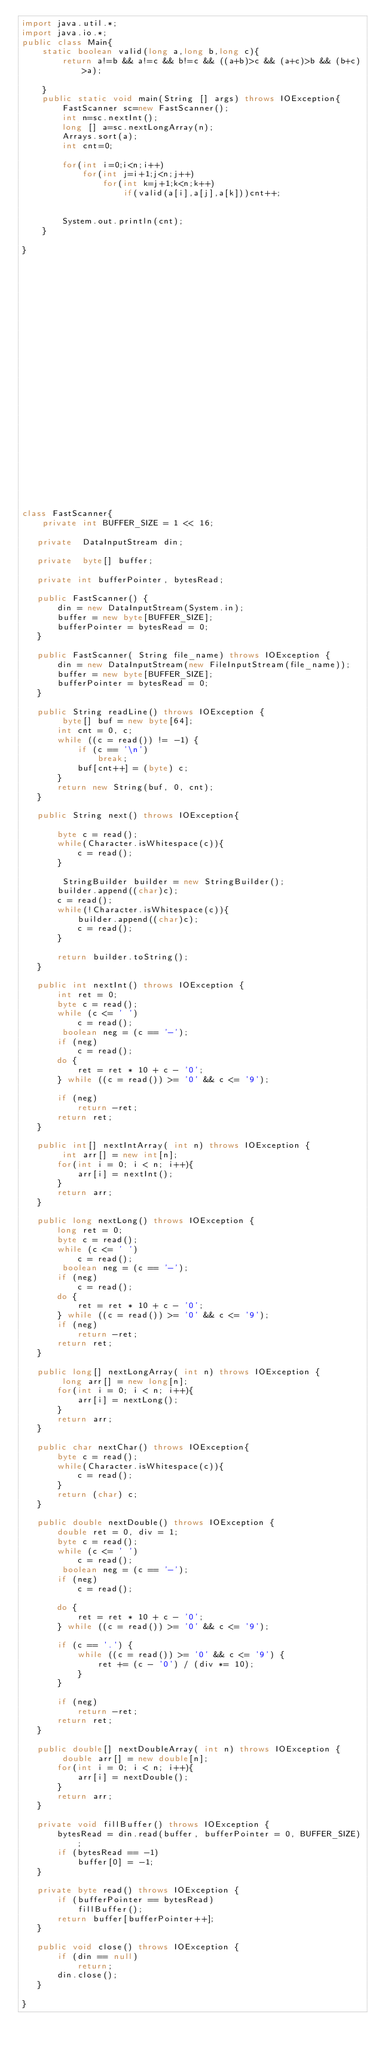Convert code to text. <code><loc_0><loc_0><loc_500><loc_500><_Java_>import java.util.*;
import java.io.*;
public class Main{
    static boolean valid(long a,long b,long c){
        return a!=b && a!=c && b!=c && ((a+b)>c && (a+c)>b && (b+c)>a);

    }
    public static void main(String [] args) throws IOException{
        FastScanner sc=new FastScanner();
        int n=sc.nextInt();
        long [] a=sc.nextLongArray(n);
        Arrays.sort(a);
        int cnt=0;

        for(int i=0;i<n;i++)
            for(int j=i+1;j<n;j++)
                for(int k=j+1;k<n;k++)
                    if(valid(a[i],a[j],a[k]))cnt++;


        System.out.println(cnt);
    }

}



























class FastScanner{	
    private int BUFFER_SIZE = 1 << 16;
   
   private  DataInputStream din;
   
   private  byte[] buffer;
   
   private int bufferPointer, bytesRead;
   
   public FastScanner() {
       din = new DataInputStream(System.in);
       buffer = new byte[BUFFER_SIZE];
       bufferPointer = bytesRead = 0;
   }

   public FastScanner( String file_name) throws IOException {
       din = new DataInputStream(new FileInputStream(file_name));
       buffer = new byte[BUFFER_SIZE];
       bufferPointer = bytesRead = 0;
   }
   
   public String readLine() throws IOException {
        byte[] buf = new byte[64];
       int cnt = 0, c;
       while ((c = read()) != -1) {
           if (c == '\n')
               break;
           buf[cnt++] = (byte) c;
       }
       return new String(buf, 0, cnt);
   }
   
   public String next() throws IOException{

       byte c = read();
       while(Character.isWhitespace(c)){
           c = read();
       }
       
        StringBuilder builder = new StringBuilder();
       builder.append((char)c);
       c = read();
       while(!Character.isWhitespace(c)){
           builder.append((char)c);
           c = read();
       }
       
       return builder.toString();
   }

   public int nextInt() throws IOException {
       int ret = 0;
       byte c = read();
       while (c <= ' ')
           c = read();
        boolean neg = (c == '-');
       if (neg)
           c = read();
       do {
           ret = ret * 10 + c - '0';
       } while ((c = read()) >= '0' && c <= '9');

       if (neg)
           return -ret;
       return ret;
   }
   
   public int[] nextIntArray( int n) throws IOException {
        int arr[] = new int[n];
       for(int i = 0; i < n; i++){
           arr[i] = nextInt();
       }
       return arr;
   }

   public long nextLong() throws IOException {
       long ret = 0;
       byte c = read();
       while (c <= ' ')
           c = read();
        boolean neg = (c == '-');
       if (neg)
           c = read();
       do {
           ret = ret * 10 + c - '0';
       } while ((c = read()) >= '0' && c <= '9');
       if (neg)
           return -ret;
       return ret;
   }
   
   public long[] nextLongArray( int n) throws IOException {
        long arr[] = new long[n];
       for(int i = 0; i < n; i++){
           arr[i] = nextLong();
       }
       return arr;
   }

   public char nextChar() throws IOException{
       byte c = read();
       while(Character.isWhitespace(c)){
           c = read();
       }
       return (char) c;	
   }
   
   public double nextDouble() throws IOException {
       double ret = 0, div = 1;
       byte c = read();
       while (c <= ' ')
           c = read();
        boolean neg = (c == '-');
       if (neg)
           c = read();

       do {
           ret = ret * 10 + c - '0';
       } while ((c = read()) >= '0' && c <= '9');

       if (c == '.') {
           while ((c = read()) >= '0' && c <= '9') {
               ret += (c - '0') / (div *= 10);
           }
       }

       if (neg)
           return -ret;
       return ret;
   }
   
   public double[] nextDoubleArray( int n) throws IOException {
        double arr[] = new double[n];
       for(int i = 0; i < n; i++){
           arr[i] = nextDouble();
       }
       return arr;
   }

   private void fillBuffer() throws IOException {
       bytesRead = din.read(buffer, bufferPointer = 0, BUFFER_SIZE);
       if (bytesRead == -1)
           buffer[0] = -1;
   }

   private byte read() throws IOException {
       if (bufferPointer == bytesRead)
           fillBuffer();
       return buffer[bufferPointer++];
   }

   public void close() throws IOException {
       if (din == null)
           return;
       din.close();
   }

}

</code> 